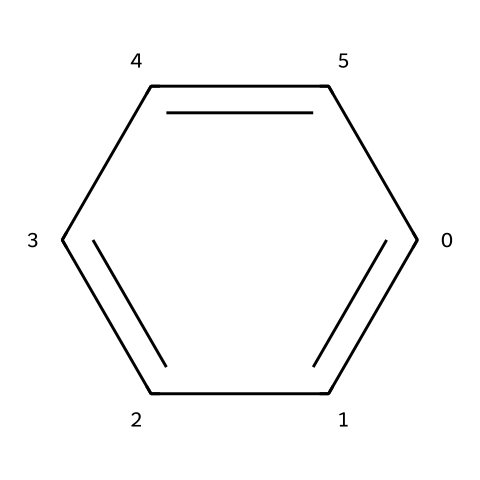What is the name of this chemical? The SMILES representation c1ccccc1 corresponds to the structure that includes six carbon atoms arranged in a cyclic manner with alternating double bonds, which is characteristic of benzene. Thus, the name is derived from its structure.
Answer: benzene How many carbon atoms are in this compound? The visual representation shows six carbon atoms arranged in a cycle. Counting these carbon atoms confirms that there are six in total.
Answer: six What type of bonds are present in this chemical structure? Analyzing the structure shows that there are both single bonds and double bonds between the carbon atoms. The alternating double bonds within the cyclic structure indicate the presence of delocalized electrons, characteristic of aromatic compounds.
Answer: alternating bonds What is the degree of unsaturation of benzene? The degree of unsaturation can be calculated based on the number of rings and double bonds. Since benzene has one ring and three double bonds (considering resonance), the total degree of unsaturation is equal to four.
Answer: four Is benzene a saturated or unsaturated compound? Given that benzene has double bonds in its structure, it is classified as an unsaturated compound. This is due to the presence of carbon-carbon double bonds, indicating that there are fewer hydrogen atoms than in a saturated hydrocarbon.
Answer: unsaturated What type of chemical family does benzene belong to? Benzene is part of the aromatic compound family, which is characterized by its cyclic structure with resonance stabilization due to its conjugated pi system. This places it in a unique category distinct from aliphatic hydrocarbons.
Answer: aromatic 